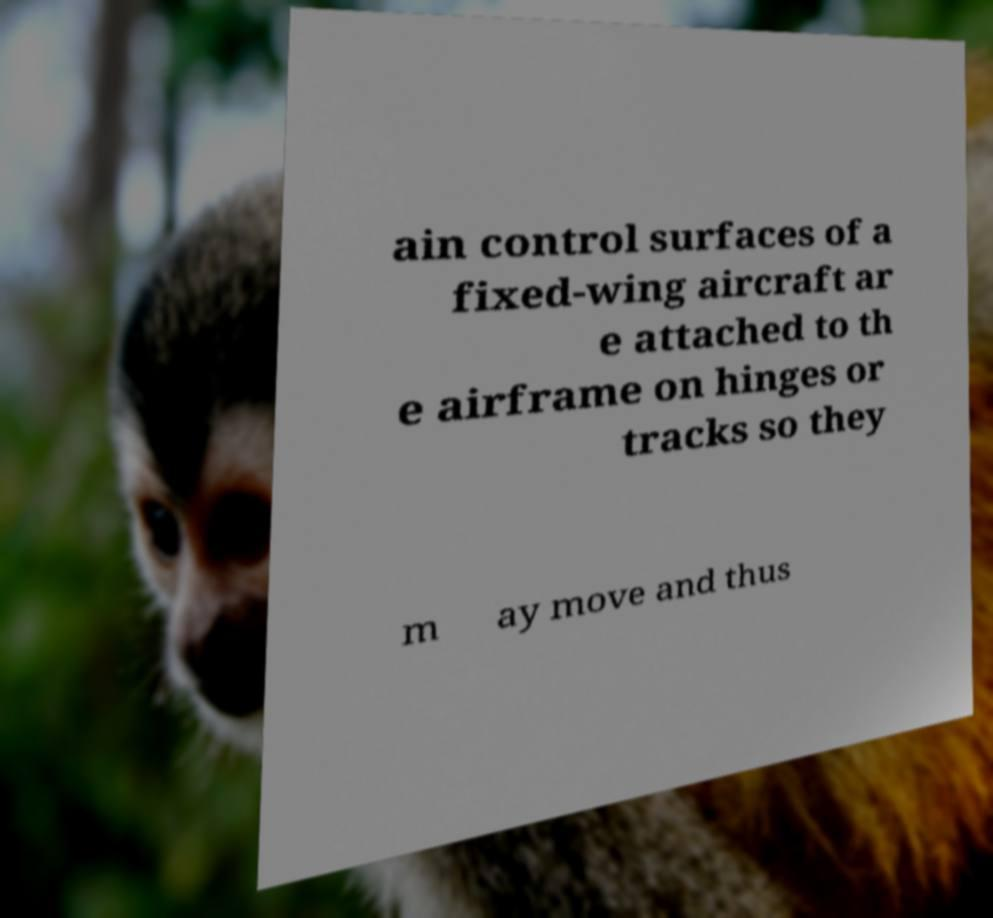There's text embedded in this image that I need extracted. Can you transcribe it verbatim? ain control surfaces of a fixed-wing aircraft ar e attached to th e airframe on hinges or tracks so they m ay move and thus 